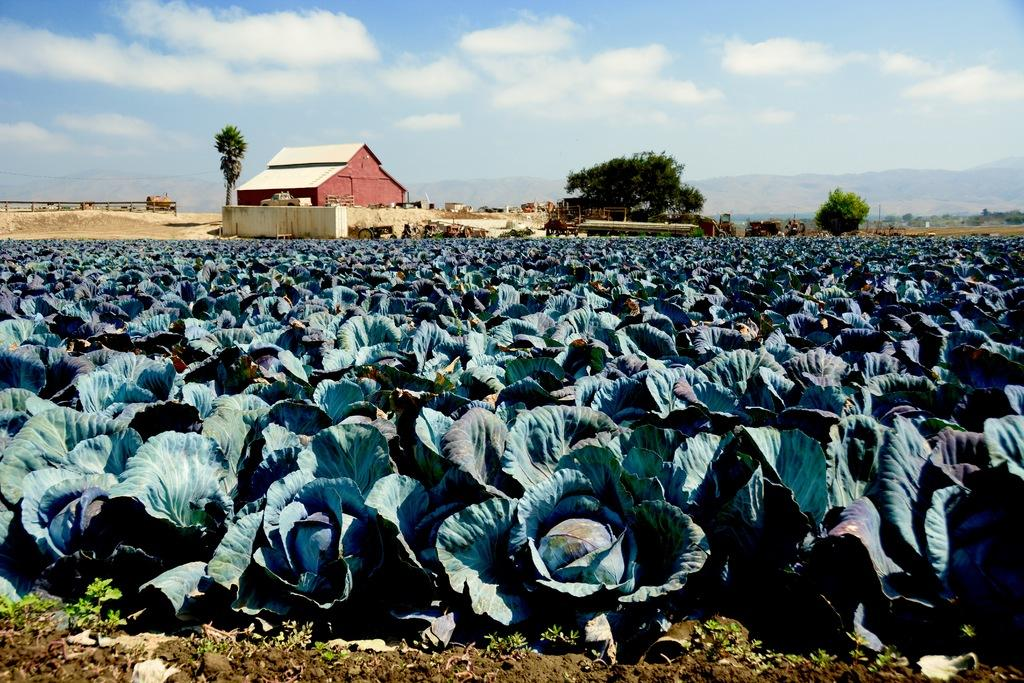What type of structure is visible in the image? There is a house in the image. What natural elements can be seen in the image? There are trees and mountains in the image. What man-made objects are present in the image? There are poles and fencing in the image. Are there any plants with a unique color in the image? Yes, there are cabbage plants with a blue color in the image. What is the color of the sky in the image? The sky is blue and white in color. What language is the pear speaking in the image? There is no pear present in the image, and therefore no language can be attributed to it. 